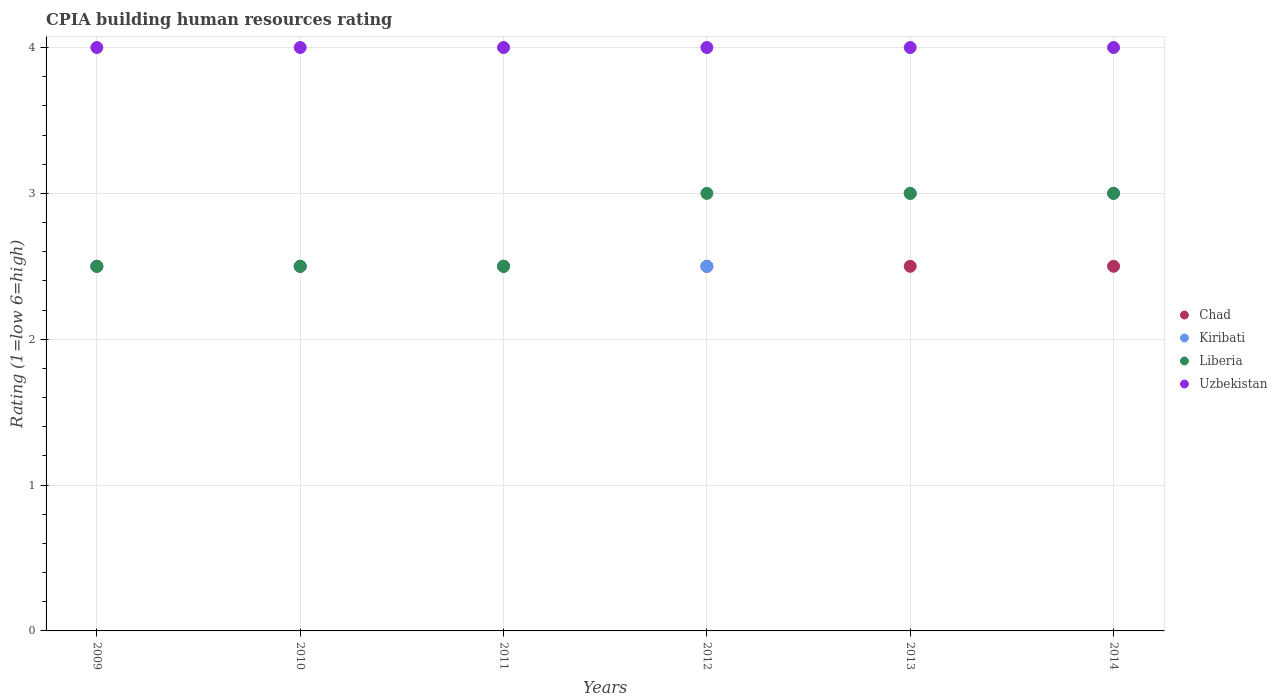How many different coloured dotlines are there?
Offer a very short reply. 4. What is the CPIA rating in Chad in 2010?
Your response must be concise. 2.5. Across all years, what is the maximum CPIA rating in Chad?
Make the answer very short. 2.5. Across all years, what is the minimum CPIA rating in Liberia?
Provide a short and direct response. 2.5. In which year was the CPIA rating in Uzbekistan maximum?
Your answer should be very brief. 2009. In which year was the CPIA rating in Liberia minimum?
Provide a short and direct response. 2009. What is the total CPIA rating in Chad in the graph?
Make the answer very short. 15. What is the difference between the CPIA rating in Liberia in 2013 and the CPIA rating in Uzbekistan in 2012?
Provide a short and direct response. -1. In how many years, is the CPIA rating in Kiribati greater than 3.2?
Offer a very short reply. 0. Is the CPIA rating in Chad in 2009 less than that in 2011?
Your response must be concise. No. Is the difference between the CPIA rating in Liberia in 2009 and 2012 greater than the difference between the CPIA rating in Chad in 2009 and 2012?
Your answer should be compact. No. What is the difference between the highest and the lowest CPIA rating in Kiribati?
Make the answer very short. 0.5. Is the sum of the CPIA rating in Liberia in 2009 and 2011 greater than the maximum CPIA rating in Chad across all years?
Give a very brief answer. Yes. Does the graph contain grids?
Provide a succinct answer. Yes. Where does the legend appear in the graph?
Provide a short and direct response. Center right. How many legend labels are there?
Your answer should be very brief. 4. How are the legend labels stacked?
Provide a short and direct response. Vertical. What is the title of the graph?
Provide a succinct answer. CPIA building human resources rating. What is the label or title of the X-axis?
Ensure brevity in your answer.  Years. What is the Rating (1=low 6=high) of Chad in 2009?
Make the answer very short. 2.5. What is the Rating (1=low 6=high) of Kiribati in 2010?
Make the answer very short. 2.5. What is the Rating (1=low 6=high) in Chad in 2011?
Make the answer very short. 2.5. What is the Rating (1=low 6=high) of Uzbekistan in 2011?
Offer a terse response. 4. What is the Rating (1=low 6=high) in Chad in 2012?
Offer a very short reply. 2.5. What is the Rating (1=low 6=high) in Kiribati in 2013?
Provide a short and direct response. 3. What is the Rating (1=low 6=high) of Liberia in 2013?
Offer a terse response. 3. What is the Rating (1=low 6=high) of Chad in 2014?
Your answer should be compact. 2.5. Across all years, what is the maximum Rating (1=low 6=high) in Chad?
Your answer should be very brief. 2.5. Across all years, what is the maximum Rating (1=low 6=high) in Kiribati?
Keep it short and to the point. 3. Across all years, what is the maximum Rating (1=low 6=high) in Liberia?
Offer a terse response. 3. Across all years, what is the minimum Rating (1=low 6=high) in Chad?
Provide a succinct answer. 2.5. What is the total Rating (1=low 6=high) in Liberia in the graph?
Offer a terse response. 16.5. What is the total Rating (1=low 6=high) in Uzbekistan in the graph?
Provide a succinct answer. 24. What is the difference between the Rating (1=low 6=high) in Liberia in 2009 and that in 2010?
Make the answer very short. 0. What is the difference between the Rating (1=low 6=high) in Chad in 2009 and that in 2011?
Provide a succinct answer. 0. What is the difference between the Rating (1=low 6=high) in Chad in 2009 and that in 2012?
Make the answer very short. 0. What is the difference between the Rating (1=low 6=high) of Liberia in 2009 and that in 2012?
Provide a succinct answer. -0.5. What is the difference between the Rating (1=low 6=high) in Uzbekistan in 2009 and that in 2012?
Keep it short and to the point. 0. What is the difference between the Rating (1=low 6=high) of Uzbekistan in 2009 and that in 2013?
Ensure brevity in your answer.  0. What is the difference between the Rating (1=low 6=high) of Chad in 2009 and that in 2014?
Your answer should be compact. 0. What is the difference between the Rating (1=low 6=high) in Kiribati in 2009 and that in 2014?
Provide a short and direct response. -0.5. What is the difference between the Rating (1=low 6=high) of Liberia in 2009 and that in 2014?
Offer a terse response. -0.5. What is the difference between the Rating (1=low 6=high) in Kiribati in 2010 and that in 2011?
Provide a succinct answer. 0. What is the difference between the Rating (1=low 6=high) of Liberia in 2010 and that in 2012?
Your response must be concise. -0.5. What is the difference between the Rating (1=low 6=high) of Uzbekistan in 2010 and that in 2012?
Keep it short and to the point. 0. What is the difference between the Rating (1=low 6=high) of Liberia in 2010 and that in 2014?
Your answer should be very brief. -0.5. What is the difference between the Rating (1=low 6=high) in Uzbekistan in 2010 and that in 2014?
Your response must be concise. 0. What is the difference between the Rating (1=low 6=high) in Chad in 2011 and that in 2012?
Offer a very short reply. 0. What is the difference between the Rating (1=low 6=high) in Kiribati in 2011 and that in 2012?
Offer a terse response. 0. What is the difference between the Rating (1=low 6=high) in Uzbekistan in 2011 and that in 2012?
Your answer should be very brief. 0. What is the difference between the Rating (1=low 6=high) of Liberia in 2011 and that in 2013?
Provide a short and direct response. -0.5. What is the difference between the Rating (1=low 6=high) in Chad in 2011 and that in 2014?
Offer a very short reply. 0. What is the difference between the Rating (1=low 6=high) of Kiribati in 2011 and that in 2014?
Give a very brief answer. -0.5. What is the difference between the Rating (1=low 6=high) of Kiribati in 2013 and that in 2014?
Provide a short and direct response. 0. What is the difference between the Rating (1=low 6=high) of Liberia in 2013 and that in 2014?
Keep it short and to the point. 0. What is the difference between the Rating (1=low 6=high) of Chad in 2009 and the Rating (1=low 6=high) of Kiribati in 2010?
Your answer should be compact. 0. What is the difference between the Rating (1=low 6=high) of Chad in 2009 and the Rating (1=low 6=high) of Liberia in 2010?
Keep it short and to the point. 0. What is the difference between the Rating (1=low 6=high) of Kiribati in 2009 and the Rating (1=low 6=high) of Uzbekistan in 2010?
Make the answer very short. -1.5. What is the difference between the Rating (1=low 6=high) in Chad in 2009 and the Rating (1=low 6=high) in Kiribati in 2011?
Offer a very short reply. 0. What is the difference between the Rating (1=low 6=high) of Kiribati in 2009 and the Rating (1=low 6=high) of Liberia in 2011?
Ensure brevity in your answer.  0. What is the difference between the Rating (1=low 6=high) of Kiribati in 2009 and the Rating (1=low 6=high) of Uzbekistan in 2011?
Provide a short and direct response. -1.5. What is the difference between the Rating (1=low 6=high) in Chad in 2009 and the Rating (1=low 6=high) in Kiribati in 2012?
Provide a short and direct response. 0. What is the difference between the Rating (1=low 6=high) in Chad in 2009 and the Rating (1=low 6=high) in Uzbekistan in 2012?
Give a very brief answer. -1.5. What is the difference between the Rating (1=low 6=high) in Kiribati in 2009 and the Rating (1=low 6=high) in Uzbekistan in 2012?
Your answer should be compact. -1.5. What is the difference between the Rating (1=low 6=high) in Chad in 2009 and the Rating (1=low 6=high) in Uzbekistan in 2013?
Your answer should be compact. -1.5. What is the difference between the Rating (1=low 6=high) in Kiribati in 2009 and the Rating (1=low 6=high) in Liberia in 2013?
Your response must be concise. -0.5. What is the difference between the Rating (1=low 6=high) in Kiribati in 2009 and the Rating (1=low 6=high) in Uzbekistan in 2013?
Give a very brief answer. -1.5. What is the difference between the Rating (1=low 6=high) in Kiribati in 2009 and the Rating (1=low 6=high) in Liberia in 2014?
Ensure brevity in your answer.  -0.5. What is the difference between the Rating (1=low 6=high) in Liberia in 2009 and the Rating (1=low 6=high) in Uzbekistan in 2014?
Your answer should be compact. -1.5. What is the difference between the Rating (1=low 6=high) in Kiribati in 2010 and the Rating (1=low 6=high) in Uzbekistan in 2011?
Give a very brief answer. -1.5. What is the difference between the Rating (1=low 6=high) in Chad in 2010 and the Rating (1=low 6=high) in Kiribati in 2012?
Give a very brief answer. 0. What is the difference between the Rating (1=low 6=high) in Chad in 2010 and the Rating (1=low 6=high) in Liberia in 2012?
Make the answer very short. -0.5. What is the difference between the Rating (1=low 6=high) of Chad in 2010 and the Rating (1=low 6=high) of Uzbekistan in 2012?
Offer a terse response. -1.5. What is the difference between the Rating (1=low 6=high) of Chad in 2010 and the Rating (1=low 6=high) of Liberia in 2013?
Provide a short and direct response. -0.5. What is the difference between the Rating (1=low 6=high) of Chad in 2010 and the Rating (1=low 6=high) of Uzbekistan in 2013?
Ensure brevity in your answer.  -1.5. What is the difference between the Rating (1=low 6=high) in Kiribati in 2010 and the Rating (1=low 6=high) in Liberia in 2013?
Your answer should be very brief. -0.5. What is the difference between the Rating (1=low 6=high) in Kiribati in 2010 and the Rating (1=low 6=high) in Uzbekistan in 2013?
Offer a very short reply. -1.5. What is the difference between the Rating (1=low 6=high) in Chad in 2010 and the Rating (1=low 6=high) in Liberia in 2014?
Keep it short and to the point. -0.5. What is the difference between the Rating (1=low 6=high) of Chad in 2010 and the Rating (1=low 6=high) of Uzbekistan in 2014?
Your answer should be very brief. -1.5. What is the difference between the Rating (1=low 6=high) in Kiribati in 2011 and the Rating (1=low 6=high) in Liberia in 2012?
Provide a succinct answer. -0.5. What is the difference between the Rating (1=low 6=high) in Kiribati in 2011 and the Rating (1=low 6=high) in Uzbekistan in 2012?
Ensure brevity in your answer.  -1.5. What is the difference between the Rating (1=low 6=high) in Liberia in 2011 and the Rating (1=low 6=high) in Uzbekistan in 2012?
Your answer should be compact. -1.5. What is the difference between the Rating (1=low 6=high) in Chad in 2011 and the Rating (1=low 6=high) in Uzbekistan in 2013?
Offer a terse response. -1.5. What is the difference between the Rating (1=low 6=high) of Kiribati in 2011 and the Rating (1=low 6=high) of Liberia in 2013?
Provide a succinct answer. -0.5. What is the difference between the Rating (1=low 6=high) of Kiribati in 2011 and the Rating (1=low 6=high) of Uzbekistan in 2013?
Make the answer very short. -1.5. What is the difference between the Rating (1=low 6=high) in Chad in 2011 and the Rating (1=low 6=high) in Kiribati in 2014?
Offer a very short reply. -0.5. What is the difference between the Rating (1=low 6=high) in Chad in 2011 and the Rating (1=low 6=high) in Liberia in 2014?
Provide a short and direct response. -0.5. What is the difference between the Rating (1=low 6=high) of Kiribati in 2011 and the Rating (1=low 6=high) of Liberia in 2014?
Your answer should be very brief. -0.5. What is the difference between the Rating (1=low 6=high) of Kiribati in 2011 and the Rating (1=low 6=high) of Uzbekistan in 2014?
Your answer should be very brief. -1.5. What is the difference between the Rating (1=low 6=high) of Chad in 2012 and the Rating (1=low 6=high) of Uzbekistan in 2013?
Make the answer very short. -1.5. What is the difference between the Rating (1=low 6=high) of Kiribati in 2012 and the Rating (1=low 6=high) of Uzbekistan in 2013?
Make the answer very short. -1.5. What is the difference between the Rating (1=low 6=high) of Kiribati in 2012 and the Rating (1=low 6=high) of Liberia in 2014?
Your answer should be very brief. -0.5. What is the difference between the Rating (1=low 6=high) in Chad in 2013 and the Rating (1=low 6=high) in Liberia in 2014?
Provide a succinct answer. -0.5. What is the difference between the Rating (1=low 6=high) in Kiribati in 2013 and the Rating (1=low 6=high) in Liberia in 2014?
Give a very brief answer. 0. What is the difference between the Rating (1=low 6=high) in Kiribati in 2013 and the Rating (1=low 6=high) in Uzbekistan in 2014?
Your answer should be compact. -1. What is the average Rating (1=low 6=high) of Chad per year?
Ensure brevity in your answer.  2.5. What is the average Rating (1=low 6=high) in Kiribati per year?
Your answer should be very brief. 2.67. What is the average Rating (1=low 6=high) in Liberia per year?
Offer a very short reply. 2.75. In the year 2009, what is the difference between the Rating (1=low 6=high) in Chad and Rating (1=low 6=high) in Liberia?
Give a very brief answer. 0. In the year 2009, what is the difference between the Rating (1=low 6=high) of Chad and Rating (1=low 6=high) of Uzbekistan?
Ensure brevity in your answer.  -1.5. In the year 2009, what is the difference between the Rating (1=low 6=high) of Kiribati and Rating (1=low 6=high) of Uzbekistan?
Your response must be concise. -1.5. In the year 2009, what is the difference between the Rating (1=low 6=high) of Liberia and Rating (1=low 6=high) of Uzbekistan?
Give a very brief answer. -1.5. In the year 2010, what is the difference between the Rating (1=low 6=high) in Chad and Rating (1=low 6=high) in Liberia?
Offer a very short reply. 0. In the year 2011, what is the difference between the Rating (1=low 6=high) in Chad and Rating (1=low 6=high) in Kiribati?
Your answer should be very brief. 0. In the year 2011, what is the difference between the Rating (1=low 6=high) in Chad and Rating (1=low 6=high) in Liberia?
Offer a very short reply. 0. In the year 2011, what is the difference between the Rating (1=low 6=high) of Chad and Rating (1=low 6=high) of Uzbekistan?
Ensure brevity in your answer.  -1.5. In the year 2011, what is the difference between the Rating (1=low 6=high) of Kiribati and Rating (1=low 6=high) of Uzbekistan?
Ensure brevity in your answer.  -1.5. In the year 2011, what is the difference between the Rating (1=low 6=high) of Liberia and Rating (1=low 6=high) of Uzbekistan?
Provide a succinct answer. -1.5. In the year 2012, what is the difference between the Rating (1=low 6=high) in Chad and Rating (1=low 6=high) in Liberia?
Provide a succinct answer. -0.5. In the year 2012, what is the difference between the Rating (1=low 6=high) of Kiribati and Rating (1=low 6=high) of Liberia?
Make the answer very short. -0.5. In the year 2012, what is the difference between the Rating (1=low 6=high) of Liberia and Rating (1=low 6=high) of Uzbekistan?
Offer a very short reply. -1. In the year 2013, what is the difference between the Rating (1=low 6=high) of Chad and Rating (1=low 6=high) of Uzbekistan?
Offer a very short reply. -1.5. In the year 2013, what is the difference between the Rating (1=low 6=high) of Kiribati and Rating (1=low 6=high) of Liberia?
Ensure brevity in your answer.  0. In the year 2014, what is the difference between the Rating (1=low 6=high) in Chad and Rating (1=low 6=high) in Kiribati?
Provide a short and direct response. -0.5. In the year 2014, what is the difference between the Rating (1=low 6=high) in Chad and Rating (1=low 6=high) in Liberia?
Offer a very short reply. -0.5. In the year 2014, what is the difference between the Rating (1=low 6=high) of Chad and Rating (1=low 6=high) of Uzbekistan?
Provide a short and direct response. -1.5. What is the ratio of the Rating (1=low 6=high) in Kiribati in 2009 to that in 2010?
Make the answer very short. 1. What is the ratio of the Rating (1=low 6=high) of Liberia in 2009 to that in 2010?
Your answer should be compact. 1. What is the ratio of the Rating (1=low 6=high) of Kiribati in 2009 to that in 2011?
Offer a very short reply. 1. What is the ratio of the Rating (1=low 6=high) in Chad in 2009 to that in 2012?
Your answer should be very brief. 1. What is the ratio of the Rating (1=low 6=high) of Kiribati in 2009 to that in 2012?
Your answer should be compact. 1. What is the ratio of the Rating (1=low 6=high) in Liberia in 2009 to that in 2012?
Provide a short and direct response. 0.83. What is the ratio of the Rating (1=low 6=high) in Uzbekistan in 2009 to that in 2012?
Your response must be concise. 1. What is the ratio of the Rating (1=low 6=high) of Liberia in 2009 to that in 2013?
Your answer should be very brief. 0.83. What is the ratio of the Rating (1=low 6=high) in Kiribati in 2009 to that in 2014?
Provide a short and direct response. 0.83. What is the ratio of the Rating (1=low 6=high) of Liberia in 2009 to that in 2014?
Your answer should be compact. 0.83. What is the ratio of the Rating (1=low 6=high) of Kiribati in 2010 to that in 2011?
Your answer should be very brief. 1. What is the ratio of the Rating (1=low 6=high) in Liberia in 2010 to that in 2011?
Make the answer very short. 1. What is the ratio of the Rating (1=low 6=high) in Liberia in 2010 to that in 2012?
Your response must be concise. 0.83. What is the ratio of the Rating (1=low 6=high) of Uzbekistan in 2010 to that in 2012?
Provide a succinct answer. 1. What is the ratio of the Rating (1=low 6=high) of Kiribati in 2010 to that in 2013?
Your response must be concise. 0.83. What is the ratio of the Rating (1=low 6=high) of Liberia in 2010 to that in 2014?
Provide a succinct answer. 0.83. What is the ratio of the Rating (1=low 6=high) in Kiribati in 2011 to that in 2012?
Provide a succinct answer. 1. What is the ratio of the Rating (1=low 6=high) in Liberia in 2011 to that in 2013?
Provide a short and direct response. 0.83. What is the ratio of the Rating (1=low 6=high) in Uzbekistan in 2011 to that in 2013?
Give a very brief answer. 1. What is the ratio of the Rating (1=low 6=high) of Chad in 2012 to that in 2013?
Offer a very short reply. 1. What is the ratio of the Rating (1=low 6=high) of Kiribati in 2012 to that in 2013?
Your response must be concise. 0.83. What is the ratio of the Rating (1=low 6=high) in Liberia in 2012 to that in 2013?
Make the answer very short. 1. What is the ratio of the Rating (1=low 6=high) of Uzbekistan in 2012 to that in 2013?
Provide a succinct answer. 1. What is the ratio of the Rating (1=low 6=high) in Liberia in 2012 to that in 2014?
Provide a short and direct response. 1. What is the ratio of the Rating (1=low 6=high) of Kiribati in 2013 to that in 2014?
Offer a terse response. 1. What is the ratio of the Rating (1=low 6=high) of Liberia in 2013 to that in 2014?
Your answer should be compact. 1. What is the ratio of the Rating (1=low 6=high) of Uzbekistan in 2013 to that in 2014?
Your response must be concise. 1. What is the difference between the highest and the second highest Rating (1=low 6=high) in Liberia?
Your answer should be very brief. 0. What is the difference between the highest and the lowest Rating (1=low 6=high) in Chad?
Offer a very short reply. 0. What is the difference between the highest and the lowest Rating (1=low 6=high) in Liberia?
Keep it short and to the point. 0.5. 